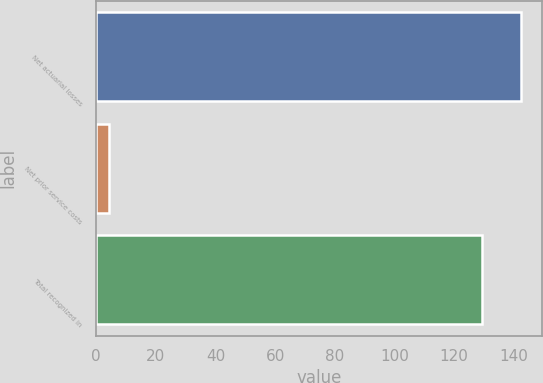Convert chart to OTSL. <chart><loc_0><loc_0><loc_500><loc_500><bar_chart><fcel>Net actuarial losses<fcel>Net prior service costs<fcel>Total recognized in<nl><fcel>142.34<fcel>4.5<fcel>129.4<nl></chart> 